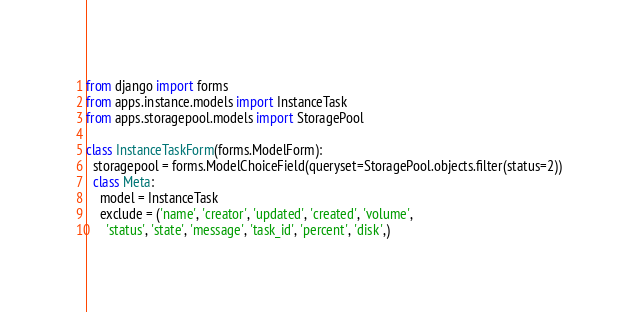<code> <loc_0><loc_0><loc_500><loc_500><_Python_>from django import forms
from apps.instance.models import InstanceTask
from apps.storagepool.models import StoragePool

class InstanceTaskForm(forms.ModelForm):
  storagepool = forms.ModelChoiceField(queryset=StoragePool.objects.filter(status=2))
  class Meta:
    model = InstanceTask
    exclude = ('name', 'creator', 'updated', 'created', 'volume',
      'status', 'state', 'message', 'task_id', 'percent', 'disk',)
</code> 